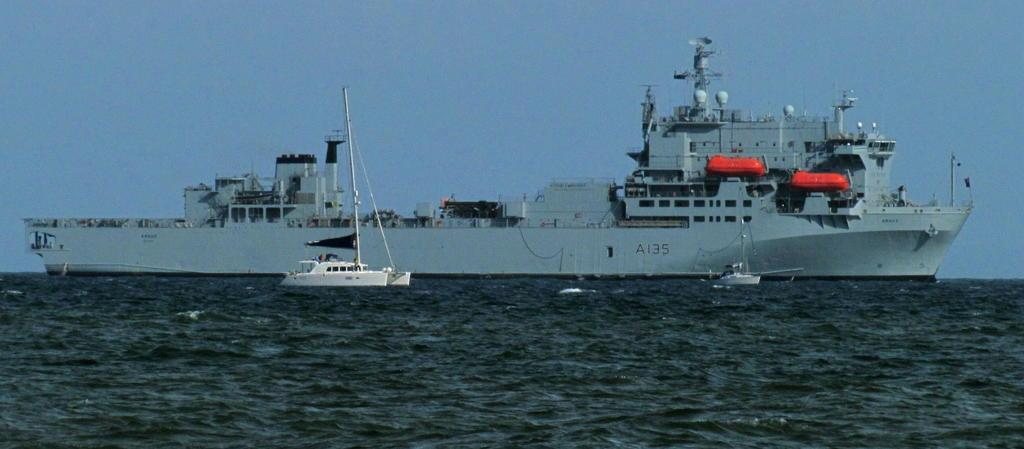Provide a one-sentence caption for the provided image. A large A135 carrier ship sails next to a smaller one. 